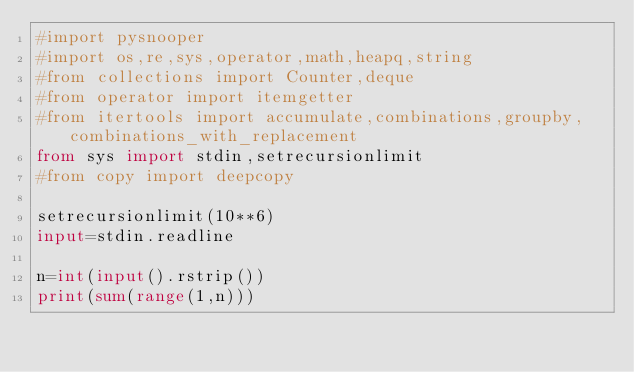<code> <loc_0><loc_0><loc_500><loc_500><_Python_>#import pysnooper
#import os,re,sys,operator,math,heapq,string
#from collections import Counter,deque
#from operator import itemgetter
#from itertools import accumulate,combinations,groupby,combinations_with_replacement
from sys import stdin,setrecursionlimit
#from copy import deepcopy

setrecursionlimit(10**6)
input=stdin.readline

n=int(input().rstrip())
print(sum(range(1,n)))</code> 